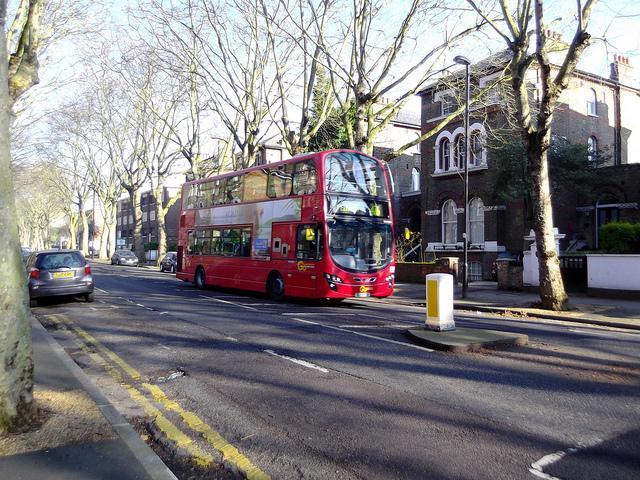How many people wearing green t shirt ?
Give a very brief answer. 0. 